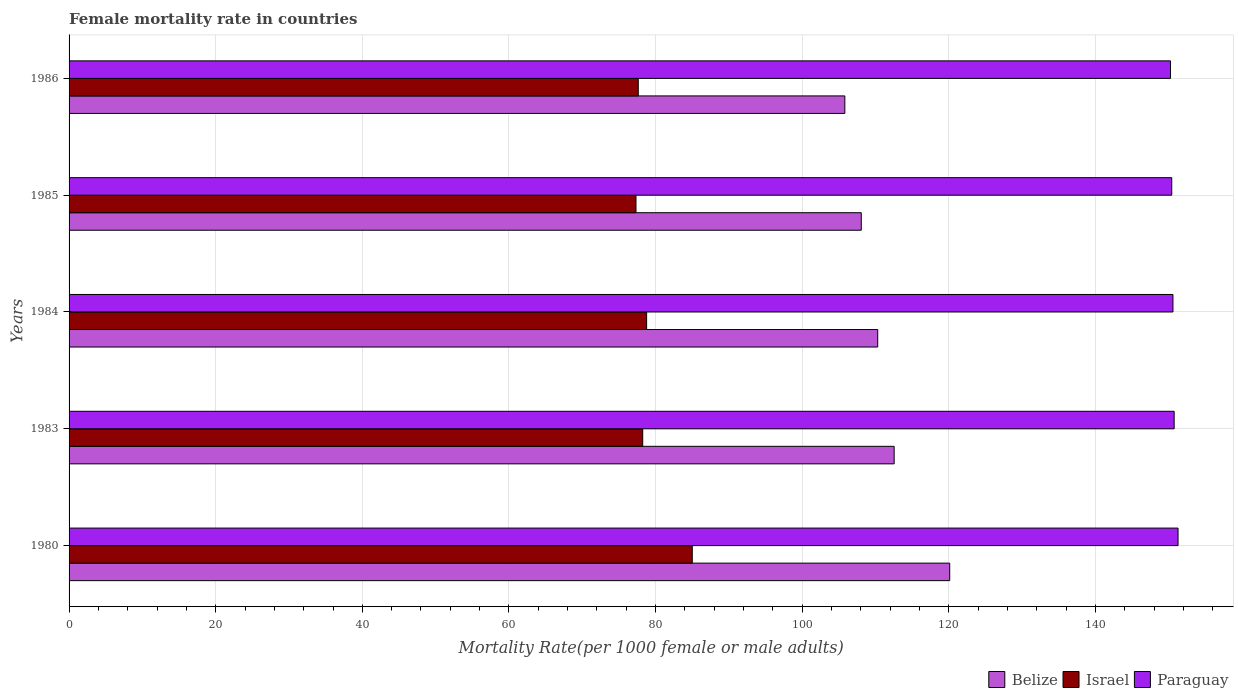How many groups of bars are there?
Your answer should be compact. 5. Are the number of bars on each tick of the Y-axis equal?
Offer a terse response. Yes. How many bars are there on the 3rd tick from the top?
Provide a succinct answer. 3. How many bars are there on the 1st tick from the bottom?
Make the answer very short. 3. In how many cases, is the number of bars for a given year not equal to the number of legend labels?
Offer a terse response. 0. What is the female mortality rate in Paraguay in 1985?
Make the answer very short. 150.4. Across all years, what is the maximum female mortality rate in Paraguay?
Your answer should be very brief. 151.26. Across all years, what is the minimum female mortality rate in Israel?
Your answer should be compact. 77.33. In which year was the female mortality rate in Belize maximum?
Offer a very short reply. 1980. In which year was the female mortality rate in Paraguay minimum?
Make the answer very short. 1986. What is the total female mortality rate in Israel in the graph?
Provide a succinct answer. 396.98. What is the difference between the female mortality rate in Belize in 1980 and that in 1983?
Your answer should be very brief. 7.58. What is the difference between the female mortality rate in Paraguay in 1983 and the female mortality rate in Belize in 1984?
Your response must be concise. 40.43. What is the average female mortality rate in Paraguay per year?
Provide a short and direct response. 150.64. In the year 1986, what is the difference between the female mortality rate in Israel and female mortality rate in Belize?
Make the answer very short. -28.17. In how many years, is the female mortality rate in Israel greater than 4 ?
Keep it short and to the point. 5. What is the ratio of the female mortality rate in Israel in 1983 to that in 1984?
Your answer should be compact. 0.99. Is the female mortality rate in Paraguay in 1980 less than that in 1984?
Give a very brief answer. No. Is the difference between the female mortality rate in Israel in 1980 and 1983 greater than the difference between the female mortality rate in Belize in 1980 and 1983?
Give a very brief answer. No. What is the difference between the highest and the second highest female mortality rate in Israel?
Make the answer very short. 6.22. What is the difference between the highest and the lowest female mortality rate in Belize?
Provide a short and direct response. 14.3. In how many years, is the female mortality rate in Israel greater than the average female mortality rate in Israel taken over all years?
Offer a very short reply. 1. What does the 2nd bar from the top in 1985 represents?
Ensure brevity in your answer.  Israel. What does the 1st bar from the bottom in 1980 represents?
Make the answer very short. Belize. How many years are there in the graph?
Make the answer very short. 5. Are the values on the major ticks of X-axis written in scientific E-notation?
Provide a short and direct response. No. What is the title of the graph?
Provide a succinct answer. Female mortality rate in countries. What is the label or title of the X-axis?
Your answer should be very brief. Mortality Rate(per 1000 female or male adults). What is the Mortality Rate(per 1000 female or male adults) in Belize in 1980?
Provide a short and direct response. 120.12. What is the Mortality Rate(per 1000 female or male adults) of Israel in 1980?
Provide a short and direct response. 85. What is the Mortality Rate(per 1000 female or male adults) of Paraguay in 1980?
Your answer should be compact. 151.26. What is the Mortality Rate(per 1000 female or male adults) in Belize in 1983?
Give a very brief answer. 112.54. What is the Mortality Rate(per 1000 female or male adults) in Israel in 1983?
Your answer should be very brief. 78.24. What is the Mortality Rate(per 1000 female or male adults) of Paraguay in 1983?
Ensure brevity in your answer.  150.73. What is the Mortality Rate(per 1000 female or male adults) of Belize in 1984?
Your response must be concise. 110.3. What is the Mortality Rate(per 1000 female or male adults) in Israel in 1984?
Your answer should be very brief. 78.78. What is the Mortality Rate(per 1000 female or male adults) in Paraguay in 1984?
Give a very brief answer. 150.56. What is the Mortality Rate(per 1000 female or male adults) in Belize in 1985?
Provide a short and direct response. 108.05. What is the Mortality Rate(per 1000 female or male adults) of Israel in 1985?
Ensure brevity in your answer.  77.33. What is the Mortality Rate(per 1000 female or male adults) of Paraguay in 1985?
Give a very brief answer. 150.4. What is the Mortality Rate(per 1000 female or male adults) in Belize in 1986?
Provide a short and direct response. 105.81. What is the Mortality Rate(per 1000 female or male adults) in Israel in 1986?
Give a very brief answer. 77.64. What is the Mortality Rate(per 1000 female or male adults) of Paraguay in 1986?
Offer a terse response. 150.23. Across all years, what is the maximum Mortality Rate(per 1000 female or male adults) in Belize?
Your response must be concise. 120.12. Across all years, what is the maximum Mortality Rate(per 1000 female or male adults) in Paraguay?
Your answer should be very brief. 151.26. Across all years, what is the minimum Mortality Rate(per 1000 female or male adults) in Belize?
Your response must be concise. 105.81. Across all years, what is the minimum Mortality Rate(per 1000 female or male adults) of Israel?
Give a very brief answer. 77.33. Across all years, what is the minimum Mortality Rate(per 1000 female or male adults) in Paraguay?
Offer a terse response. 150.23. What is the total Mortality Rate(per 1000 female or male adults) in Belize in the graph?
Give a very brief answer. 556.81. What is the total Mortality Rate(per 1000 female or male adults) of Israel in the graph?
Your response must be concise. 396.98. What is the total Mortality Rate(per 1000 female or male adults) in Paraguay in the graph?
Keep it short and to the point. 753.18. What is the difference between the Mortality Rate(per 1000 female or male adults) of Belize in 1980 and that in 1983?
Your response must be concise. 7.58. What is the difference between the Mortality Rate(per 1000 female or male adults) in Israel in 1980 and that in 1983?
Provide a short and direct response. 6.76. What is the difference between the Mortality Rate(per 1000 female or male adults) in Paraguay in 1980 and that in 1983?
Offer a very short reply. 0.53. What is the difference between the Mortality Rate(per 1000 female or male adults) of Belize in 1980 and that in 1984?
Ensure brevity in your answer.  9.82. What is the difference between the Mortality Rate(per 1000 female or male adults) of Israel in 1980 and that in 1984?
Give a very brief answer. 6.22. What is the difference between the Mortality Rate(per 1000 female or male adults) in Paraguay in 1980 and that in 1984?
Ensure brevity in your answer.  0.69. What is the difference between the Mortality Rate(per 1000 female or male adults) in Belize in 1980 and that in 1985?
Provide a succinct answer. 12.06. What is the difference between the Mortality Rate(per 1000 female or male adults) in Israel in 1980 and that in 1985?
Make the answer very short. 7.67. What is the difference between the Mortality Rate(per 1000 female or male adults) in Paraguay in 1980 and that in 1985?
Your response must be concise. 0.86. What is the difference between the Mortality Rate(per 1000 female or male adults) in Belize in 1980 and that in 1986?
Your answer should be compact. 14.3. What is the difference between the Mortality Rate(per 1000 female or male adults) in Israel in 1980 and that in 1986?
Give a very brief answer. 7.36. What is the difference between the Mortality Rate(per 1000 female or male adults) in Paraguay in 1980 and that in 1986?
Your answer should be compact. 1.03. What is the difference between the Mortality Rate(per 1000 female or male adults) in Belize in 1983 and that in 1984?
Offer a terse response. 2.24. What is the difference between the Mortality Rate(per 1000 female or male adults) in Israel in 1983 and that in 1984?
Your answer should be very brief. -0.53. What is the difference between the Mortality Rate(per 1000 female or male adults) in Paraguay in 1983 and that in 1984?
Your answer should be compact. 0.17. What is the difference between the Mortality Rate(per 1000 female or male adults) in Belize in 1983 and that in 1985?
Your answer should be compact. 4.49. What is the difference between the Mortality Rate(per 1000 female or male adults) of Israel in 1983 and that in 1985?
Your answer should be very brief. 0.92. What is the difference between the Mortality Rate(per 1000 female or male adults) in Paraguay in 1983 and that in 1985?
Your response must be concise. 0.33. What is the difference between the Mortality Rate(per 1000 female or male adults) of Belize in 1983 and that in 1986?
Offer a very short reply. 6.73. What is the difference between the Mortality Rate(per 1000 female or male adults) of Israel in 1983 and that in 1986?
Your answer should be compact. 0.61. What is the difference between the Mortality Rate(per 1000 female or male adults) of Paraguay in 1983 and that in 1986?
Provide a short and direct response. 0.5. What is the difference between the Mortality Rate(per 1000 female or male adults) of Belize in 1984 and that in 1985?
Your response must be concise. 2.24. What is the difference between the Mortality Rate(per 1000 female or male adults) in Israel in 1984 and that in 1985?
Your response must be concise. 1.45. What is the difference between the Mortality Rate(per 1000 female or male adults) in Paraguay in 1984 and that in 1985?
Ensure brevity in your answer.  0.17. What is the difference between the Mortality Rate(per 1000 female or male adults) of Belize in 1984 and that in 1986?
Keep it short and to the point. 4.48. What is the difference between the Mortality Rate(per 1000 female or male adults) of Israel in 1984 and that in 1986?
Your answer should be very brief. 1.14. What is the difference between the Mortality Rate(per 1000 female or male adults) of Paraguay in 1984 and that in 1986?
Offer a very short reply. 0.33. What is the difference between the Mortality Rate(per 1000 female or male adults) in Belize in 1985 and that in 1986?
Offer a very short reply. 2.24. What is the difference between the Mortality Rate(per 1000 female or male adults) of Israel in 1985 and that in 1986?
Keep it short and to the point. -0.31. What is the difference between the Mortality Rate(per 1000 female or male adults) in Paraguay in 1985 and that in 1986?
Your answer should be compact. 0.17. What is the difference between the Mortality Rate(per 1000 female or male adults) of Belize in 1980 and the Mortality Rate(per 1000 female or male adults) of Israel in 1983?
Keep it short and to the point. 41.87. What is the difference between the Mortality Rate(per 1000 female or male adults) in Belize in 1980 and the Mortality Rate(per 1000 female or male adults) in Paraguay in 1983?
Offer a very short reply. -30.61. What is the difference between the Mortality Rate(per 1000 female or male adults) in Israel in 1980 and the Mortality Rate(per 1000 female or male adults) in Paraguay in 1983?
Provide a short and direct response. -65.73. What is the difference between the Mortality Rate(per 1000 female or male adults) of Belize in 1980 and the Mortality Rate(per 1000 female or male adults) of Israel in 1984?
Keep it short and to the point. 41.34. What is the difference between the Mortality Rate(per 1000 female or male adults) in Belize in 1980 and the Mortality Rate(per 1000 female or male adults) in Paraguay in 1984?
Make the answer very short. -30.45. What is the difference between the Mortality Rate(per 1000 female or male adults) of Israel in 1980 and the Mortality Rate(per 1000 female or male adults) of Paraguay in 1984?
Ensure brevity in your answer.  -65.56. What is the difference between the Mortality Rate(per 1000 female or male adults) of Belize in 1980 and the Mortality Rate(per 1000 female or male adults) of Israel in 1985?
Ensure brevity in your answer.  42.79. What is the difference between the Mortality Rate(per 1000 female or male adults) in Belize in 1980 and the Mortality Rate(per 1000 female or male adults) in Paraguay in 1985?
Your answer should be very brief. -30.28. What is the difference between the Mortality Rate(per 1000 female or male adults) of Israel in 1980 and the Mortality Rate(per 1000 female or male adults) of Paraguay in 1985?
Offer a very short reply. -65.4. What is the difference between the Mortality Rate(per 1000 female or male adults) in Belize in 1980 and the Mortality Rate(per 1000 female or male adults) in Israel in 1986?
Keep it short and to the point. 42.48. What is the difference between the Mortality Rate(per 1000 female or male adults) of Belize in 1980 and the Mortality Rate(per 1000 female or male adults) of Paraguay in 1986?
Offer a very short reply. -30.12. What is the difference between the Mortality Rate(per 1000 female or male adults) in Israel in 1980 and the Mortality Rate(per 1000 female or male adults) in Paraguay in 1986?
Keep it short and to the point. -65.23. What is the difference between the Mortality Rate(per 1000 female or male adults) of Belize in 1983 and the Mortality Rate(per 1000 female or male adults) of Israel in 1984?
Your answer should be very brief. 33.76. What is the difference between the Mortality Rate(per 1000 female or male adults) in Belize in 1983 and the Mortality Rate(per 1000 female or male adults) in Paraguay in 1984?
Give a very brief answer. -38.03. What is the difference between the Mortality Rate(per 1000 female or male adults) of Israel in 1983 and the Mortality Rate(per 1000 female or male adults) of Paraguay in 1984?
Offer a very short reply. -72.32. What is the difference between the Mortality Rate(per 1000 female or male adults) of Belize in 1983 and the Mortality Rate(per 1000 female or male adults) of Israel in 1985?
Your response must be concise. 35.21. What is the difference between the Mortality Rate(per 1000 female or male adults) in Belize in 1983 and the Mortality Rate(per 1000 female or male adults) in Paraguay in 1985?
Your answer should be very brief. -37.86. What is the difference between the Mortality Rate(per 1000 female or male adults) of Israel in 1983 and the Mortality Rate(per 1000 female or male adults) of Paraguay in 1985?
Provide a succinct answer. -72.15. What is the difference between the Mortality Rate(per 1000 female or male adults) in Belize in 1983 and the Mortality Rate(per 1000 female or male adults) in Israel in 1986?
Your response must be concise. 34.9. What is the difference between the Mortality Rate(per 1000 female or male adults) in Belize in 1983 and the Mortality Rate(per 1000 female or male adults) in Paraguay in 1986?
Offer a terse response. -37.7. What is the difference between the Mortality Rate(per 1000 female or male adults) of Israel in 1983 and the Mortality Rate(per 1000 female or male adults) of Paraguay in 1986?
Give a very brief answer. -71.99. What is the difference between the Mortality Rate(per 1000 female or male adults) of Belize in 1984 and the Mortality Rate(per 1000 female or male adults) of Israel in 1985?
Provide a short and direct response. 32.97. What is the difference between the Mortality Rate(per 1000 female or male adults) in Belize in 1984 and the Mortality Rate(per 1000 female or male adults) in Paraguay in 1985?
Keep it short and to the point. -40.1. What is the difference between the Mortality Rate(per 1000 female or male adults) in Israel in 1984 and the Mortality Rate(per 1000 female or male adults) in Paraguay in 1985?
Your response must be concise. -71.62. What is the difference between the Mortality Rate(per 1000 female or male adults) of Belize in 1984 and the Mortality Rate(per 1000 female or male adults) of Israel in 1986?
Give a very brief answer. 32.66. What is the difference between the Mortality Rate(per 1000 female or male adults) in Belize in 1984 and the Mortality Rate(per 1000 female or male adults) in Paraguay in 1986?
Ensure brevity in your answer.  -39.94. What is the difference between the Mortality Rate(per 1000 female or male adults) in Israel in 1984 and the Mortality Rate(per 1000 female or male adults) in Paraguay in 1986?
Make the answer very short. -71.46. What is the difference between the Mortality Rate(per 1000 female or male adults) in Belize in 1985 and the Mortality Rate(per 1000 female or male adults) in Israel in 1986?
Ensure brevity in your answer.  30.42. What is the difference between the Mortality Rate(per 1000 female or male adults) of Belize in 1985 and the Mortality Rate(per 1000 female or male adults) of Paraguay in 1986?
Keep it short and to the point. -42.18. What is the difference between the Mortality Rate(per 1000 female or male adults) of Israel in 1985 and the Mortality Rate(per 1000 female or male adults) of Paraguay in 1986?
Give a very brief answer. -72.91. What is the average Mortality Rate(per 1000 female or male adults) of Belize per year?
Your answer should be very brief. 111.36. What is the average Mortality Rate(per 1000 female or male adults) of Israel per year?
Your answer should be very brief. 79.4. What is the average Mortality Rate(per 1000 female or male adults) of Paraguay per year?
Keep it short and to the point. 150.64. In the year 1980, what is the difference between the Mortality Rate(per 1000 female or male adults) of Belize and Mortality Rate(per 1000 female or male adults) of Israel?
Your response must be concise. 35.12. In the year 1980, what is the difference between the Mortality Rate(per 1000 female or male adults) of Belize and Mortality Rate(per 1000 female or male adults) of Paraguay?
Make the answer very short. -31.14. In the year 1980, what is the difference between the Mortality Rate(per 1000 female or male adults) of Israel and Mortality Rate(per 1000 female or male adults) of Paraguay?
Provide a short and direct response. -66.26. In the year 1983, what is the difference between the Mortality Rate(per 1000 female or male adults) in Belize and Mortality Rate(per 1000 female or male adults) in Israel?
Your answer should be very brief. 34.29. In the year 1983, what is the difference between the Mortality Rate(per 1000 female or male adults) in Belize and Mortality Rate(per 1000 female or male adults) in Paraguay?
Make the answer very short. -38.19. In the year 1983, what is the difference between the Mortality Rate(per 1000 female or male adults) in Israel and Mortality Rate(per 1000 female or male adults) in Paraguay?
Give a very brief answer. -72.48. In the year 1984, what is the difference between the Mortality Rate(per 1000 female or male adults) in Belize and Mortality Rate(per 1000 female or male adults) in Israel?
Give a very brief answer. 31.52. In the year 1984, what is the difference between the Mortality Rate(per 1000 female or male adults) in Belize and Mortality Rate(per 1000 female or male adults) in Paraguay?
Keep it short and to the point. -40.27. In the year 1984, what is the difference between the Mortality Rate(per 1000 female or male adults) of Israel and Mortality Rate(per 1000 female or male adults) of Paraguay?
Give a very brief answer. -71.79. In the year 1985, what is the difference between the Mortality Rate(per 1000 female or male adults) in Belize and Mortality Rate(per 1000 female or male adults) in Israel?
Provide a short and direct response. 30.73. In the year 1985, what is the difference between the Mortality Rate(per 1000 female or male adults) in Belize and Mortality Rate(per 1000 female or male adults) in Paraguay?
Your response must be concise. -42.34. In the year 1985, what is the difference between the Mortality Rate(per 1000 female or male adults) in Israel and Mortality Rate(per 1000 female or male adults) in Paraguay?
Your answer should be very brief. -73.07. In the year 1986, what is the difference between the Mortality Rate(per 1000 female or male adults) of Belize and Mortality Rate(per 1000 female or male adults) of Israel?
Your response must be concise. 28.18. In the year 1986, what is the difference between the Mortality Rate(per 1000 female or male adults) of Belize and Mortality Rate(per 1000 female or male adults) of Paraguay?
Your answer should be very brief. -44.42. In the year 1986, what is the difference between the Mortality Rate(per 1000 female or male adults) of Israel and Mortality Rate(per 1000 female or male adults) of Paraguay?
Ensure brevity in your answer.  -72.6. What is the ratio of the Mortality Rate(per 1000 female or male adults) of Belize in 1980 to that in 1983?
Your answer should be compact. 1.07. What is the ratio of the Mortality Rate(per 1000 female or male adults) in Israel in 1980 to that in 1983?
Give a very brief answer. 1.09. What is the ratio of the Mortality Rate(per 1000 female or male adults) in Paraguay in 1980 to that in 1983?
Make the answer very short. 1. What is the ratio of the Mortality Rate(per 1000 female or male adults) of Belize in 1980 to that in 1984?
Keep it short and to the point. 1.09. What is the ratio of the Mortality Rate(per 1000 female or male adults) in Israel in 1980 to that in 1984?
Your response must be concise. 1.08. What is the ratio of the Mortality Rate(per 1000 female or male adults) in Belize in 1980 to that in 1985?
Your answer should be very brief. 1.11. What is the ratio of the Mortality Rate(per 1000 female or male adults) in Israel in 1980 to that in 1985?
Your answer should be very brief. 1.1. What is the ratio of the Mortality Rate(per 1000 female or male adults) of Belize in 1980 to that in 1986?
Keep it short and to the point. 1.14. What is the ratio of the Mortality Rate(per 1000 female or male adults) in Israel in 1980 to that in 1986?
Give a very brief answer. 1.09. What is the ratio of the Mortality Rate(per 1000 female or male adults) in Paraguay in 1980 to that in 1986?
Give a very brief answer. 1.01. What is the ratio of the Mortality Rate(per 1000 female or male adults) in Belize in 1983 to that in 1984?
Keep it short and to the point. 1.02. What is the ratio of the Mortality Rate(per 1000 female or male adults) of Israel in 1983 to that in 1984?
Provide a succinct answer. 0.99. What is the ratio of the Mortality Rate(per 1000 female or male adults) of Belize in 1983 to that in 1985?
Provide a succinct answer. 1.04. What is the ratio of the Mortality Rate(per 1000 female or male adults) of Israel in 1983 to that in 1985?
Provide a short and direct response. 1.01. What is the ratio of the Mortality Rate(per 1000 female or male adults) of Paraguay in 1983 to that in 1985?
Provide a succinct answer. 1. What is the ratio of the Mortality Rate(per 1000 female or male adults) in Belize in 1983 to that in 1986?
Make the answer very short. 1.06. What is the ratio of the Mortality Rate(per 1000 female or male adults) in Paraguay in 1983 to that in 1986?
Provide a succinct answer. 1. What is the ratio of the Mortality Rate(per 1000 female or male adults) of Belize in 1984 to that in 1985?
Provide a short and direct response. 1.02. What is the ratio of the Mortality Rate(per 1000 female or male adults) of Israel in 1984 to that in 1985?
Make the answer very short. 1.02. What is the ratio of the Mortality Rate(per 1000 female or male adults) of Paraguay in 1984 to that in 1985?
Your response must be concise. 1. What is the ratio of the Mortality Rate(per 1000 female or male adults) in Belize in 1984 to that in 1986?
Offer a terse response. 1.04. What is the ratio of the Mortality Rate(per 1000 female or male adults) of Israel in 1984 to that in 1986?
Your answer should be compact. 1.01. What is the ratio of the Mortality Rate(per 1000 female or male adults) in Paraguay in 1984 to that in 1986?
Make the answer very short. 1. What is the ratio of the Mortality Rate(per 1000 female or male adults) in Belize in 1985 to that in 1986?
Ensure brevity in your answer.  1.02. What is the difference between the highest and the second highest Mortality Rate(per 1000 female or male adults) of Belize?
Your response must be concise. 7.58. What is the difference between the highest and the second highest Mortality Rate(per 1000 female or male adults) of Israel?
Make the answer very short. 6.22. What is the difference between the highest and the second highest Mortality Rate(per 1000 female or male adults) of Paraguay?
Your answer should be very brief. 0.53. What is the difference between the highest and the lowest Mortality Rate(per 1000 female or male adults) of Belize?
Offer a terse response. 14.3. What is the difference between the highest and the lowest Mortality Rate(per 1000 female or male adults) in Israel?
Your response must be concise. 7.67. What is the difference between the highest and the lowest Mortality Rate(per 1000 female or male adults) of Paraguay?
Your answer should be very brief. 1.03. 